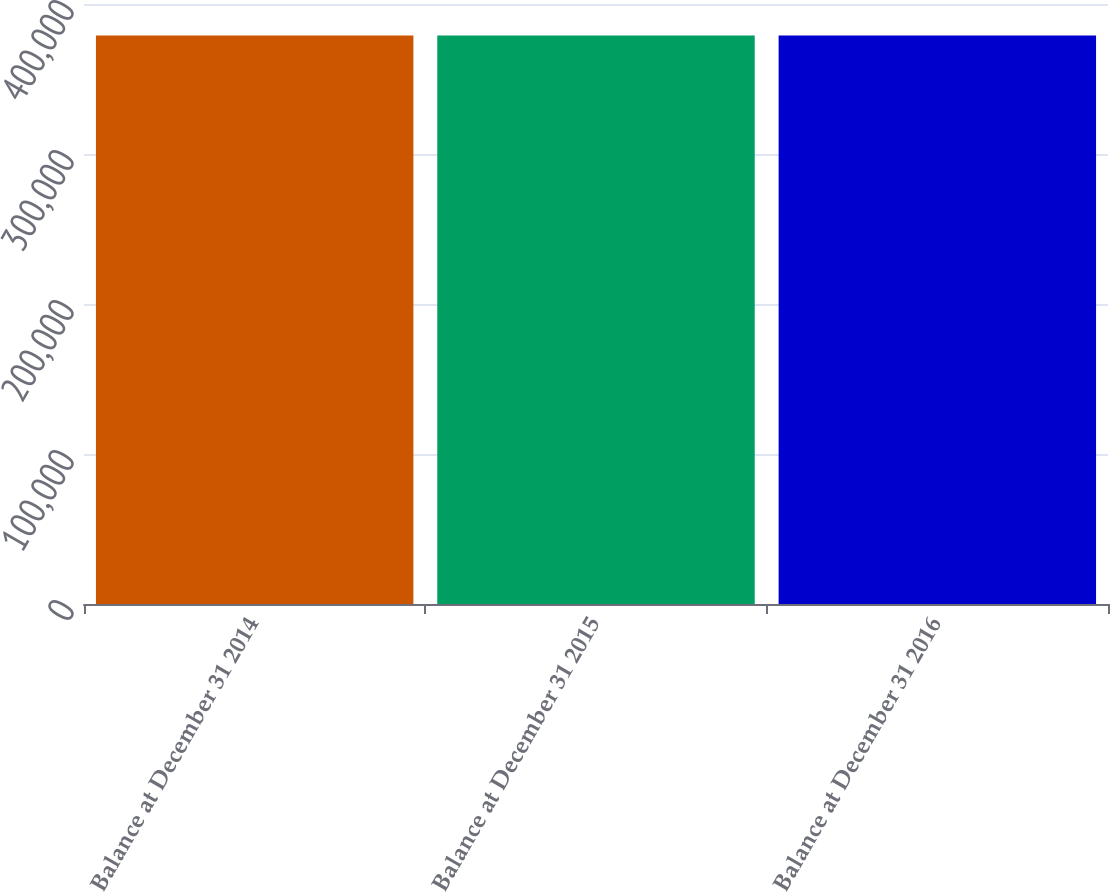Convert chart to OTSL. <chart><loc_0><loc_0><loc_500><loc_500><bar_chart><fcel>Balance at December 31 2014<fcel>Balance at December 31 2015<fcel>Balance at December 31 2016<nl><fcel>379024<fcel>379024<fcel>379024<nl></chart> 